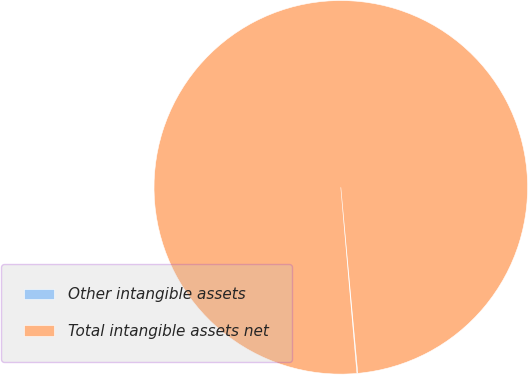Convert chart to OTSL. <chart><loc_0><loc_0><loc_500><loc_500><pie_chart><fcel>Other intangible assets<fcel>Total intangible assets net<nl><fcel>0.07%<fcel>99.93%<nl></chart> 